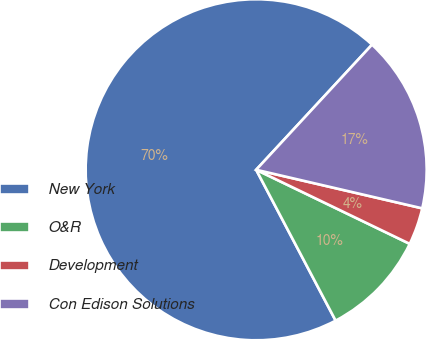<chart> <loc_0><loc_0><loc_500><loc_500><pie_chart><fcel>New York<fcel>O&R<fcel>Development<fcel>Con Edison Solutions<nl><fcel>69.6%<fcel>10.13%<fcel>3.52%<fcel>16.74%<nl></chart> 